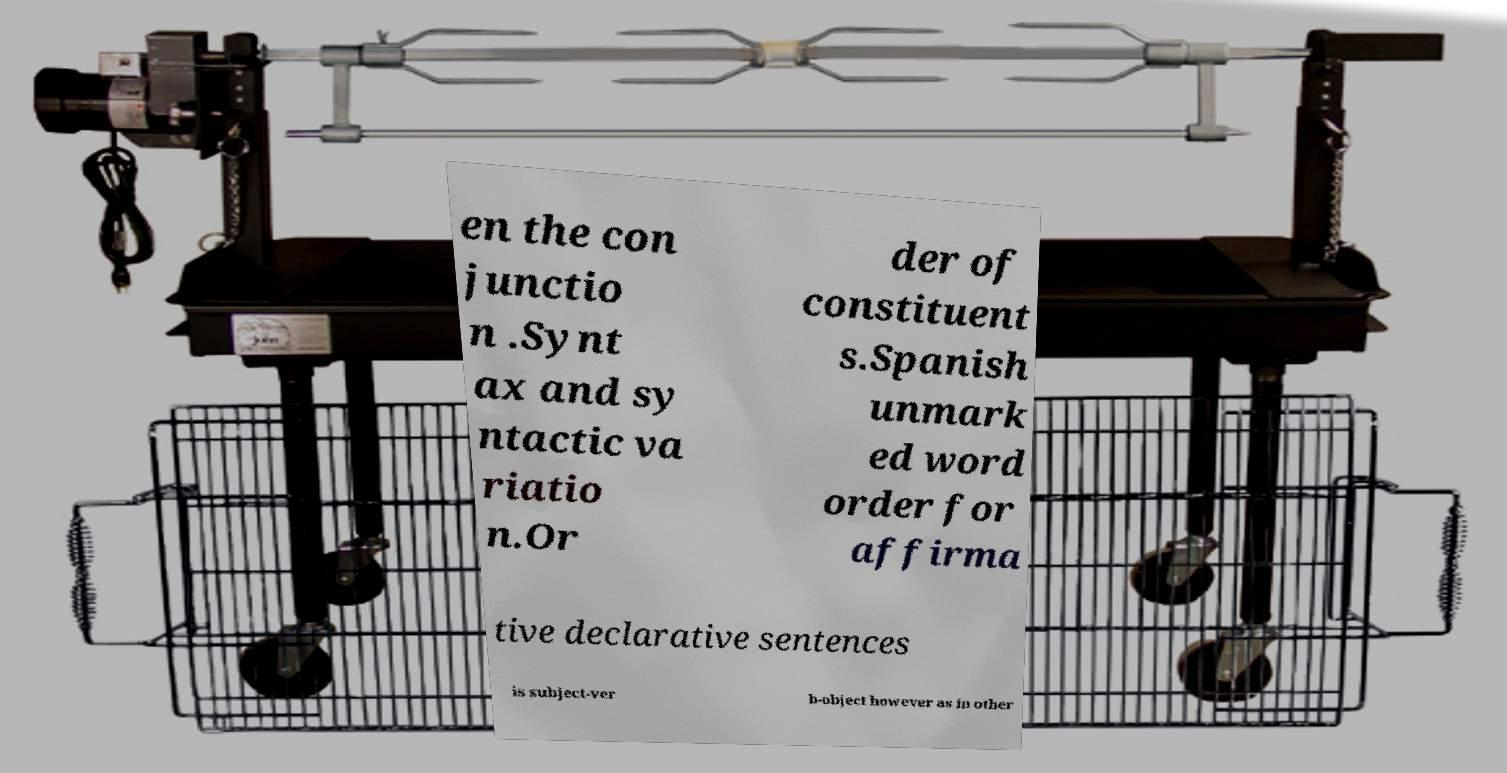There's text embedded in this image that I need extracted. Can you transcribe it verbatim? en the con junctio n .Synt ax and sy ntactic va riatio n.Or der of constituent s.Spanish unmark ed word order for affirma tive declarative sentences is subject-ver b-object however as in other 